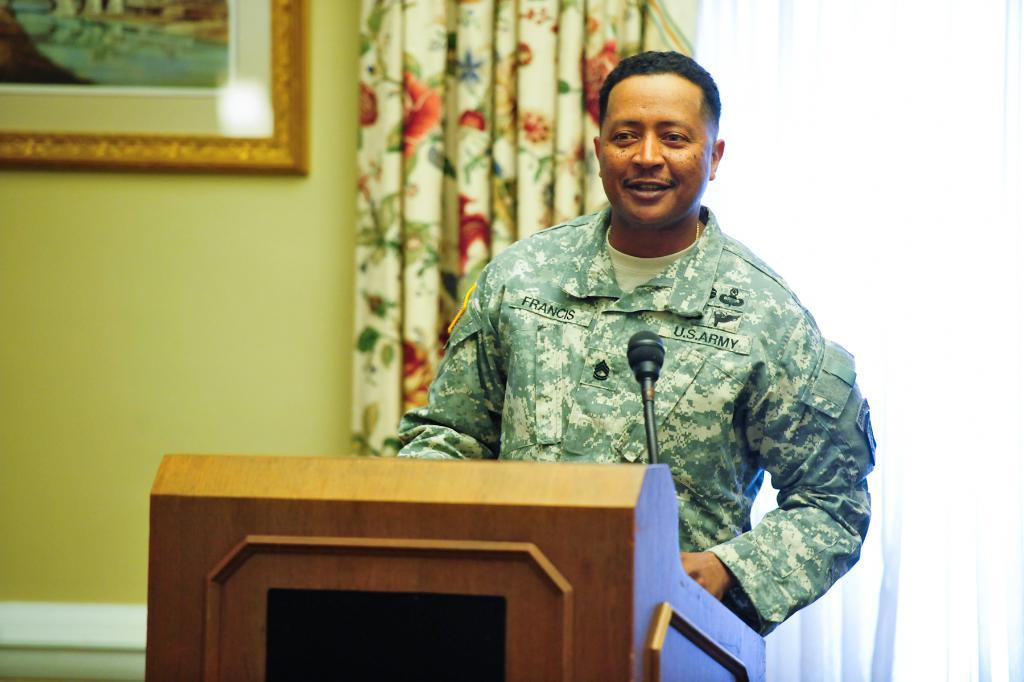What is the main subject in the foreground of the image? There is a man in the foreground of the image. What is the man standing in front of? The man is standing in front of a podium. What can be found on the podium? There is a mic on the podium. What can be seen in the background of the image? There is a curtain, a window blind, and a frame on the wall in the background of the image. What time of day is it in the image, and how many boys are present? The time of day cannot be determined from the image, and there are no boys present in the image. 